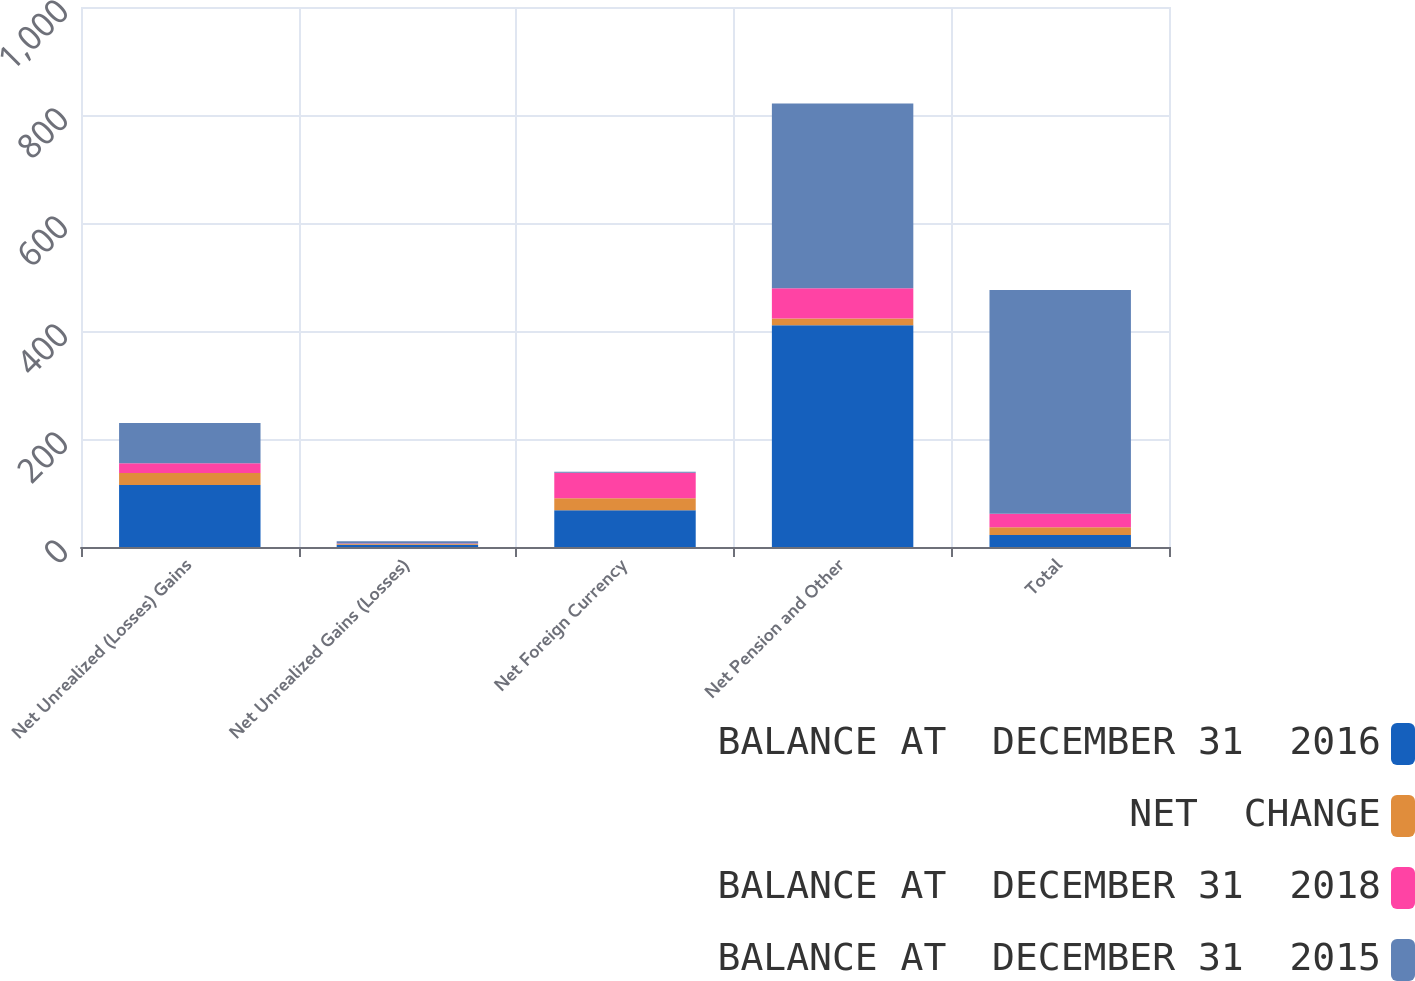Convert chart to OTSL. <chart><loc_0><loc_0><loc_500><loc_500><stacked_bar_chart><ecel><fcel>Net Unrealized (Losses) Gains<fcel>Net Unrealized Gains (Losses)<fcel>Net Foreign Currency<fcel>Net Pension and Other<fcel>Total<nl><fcel>BALANCE AT  DECEMBER 31  2016<fcel>114.9<fcel>4<fcel>67.9<fcel>410.7<fcel>22.3<nl><fcel>NET  CHANGE<fcel>22.3<fcel>1.4<fcel>22.2<fcel>12.6<fcel>14.1<nl><fcel>BALANCE AT  DECEMBER 31  2018<fcel>17.8<fcel>0.9<fcel>47.5<fcel>55.9<fcel>25.3<nl><fcel>BALANCE AT  DECEMBER 31  2015<fcel>74.8<fcel>4.5<fcel>1.8<fcel>342.2<fcel>414.3<nl></chart> 